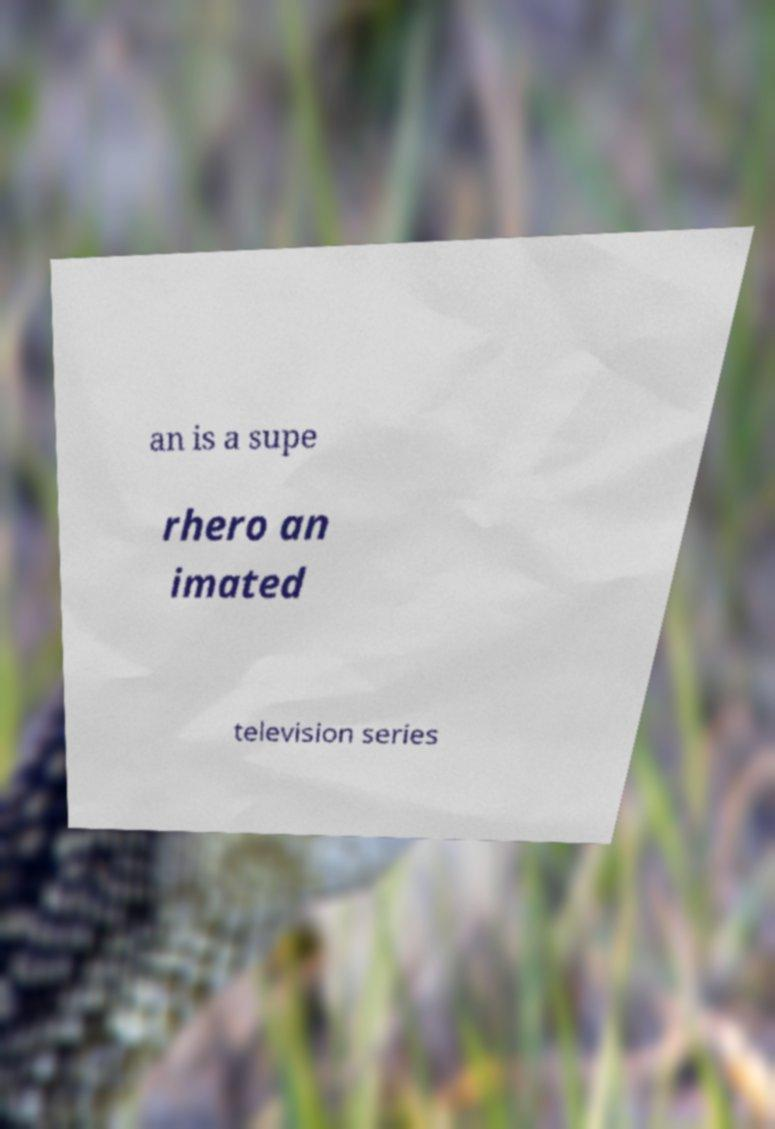Please identify and transcribe the text found in this image. an is a supe rhero an imated television series 